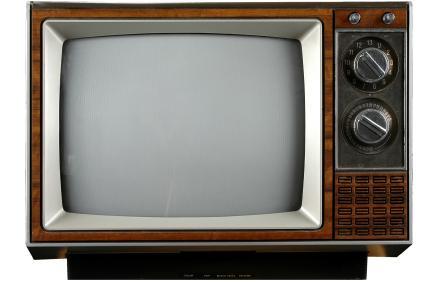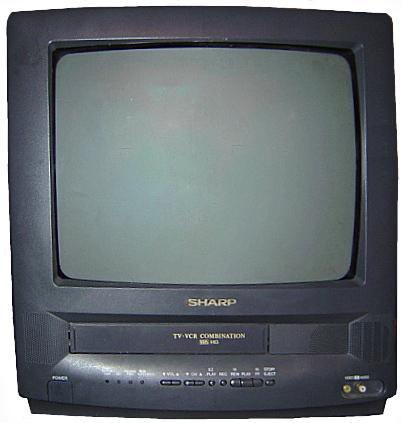The first image is the image on the left, the second image is the image on the right. Given the left and right images, does the statement "Two televisions have the same boxy shape and screens, but one has visible tuning controls at the bottom while the other has a small panel door in the same place." hold true? Answer yes or no. No. The first image is the image on the left, the second image is the image on the right. Given the left and right images, does the statement "One image shows an old-fashioned TV set with two large knobs arranged vertically alongside the screen." hold true? Answer yes or no. Yes. 